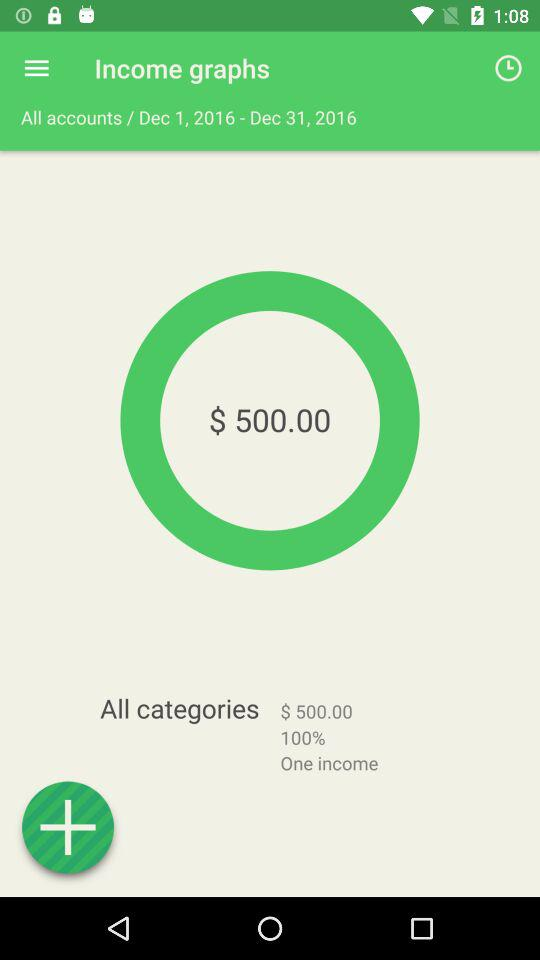What percentage of the total income is from one income?
Answer the question using a single word or phrase. 100% 